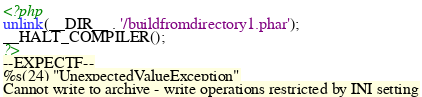<code> <loc_0><loc_0><loc_500><loc_500><_PHP_><?php
unlink(__DIR__ . '/buildfromdirectory1.phar');
__HALT_COMPILER();
?>
--EXPECTF--
%s(24) "UnexpectedValueException"
Cannot write to archive - write operations restricted by INI setting
</code> 